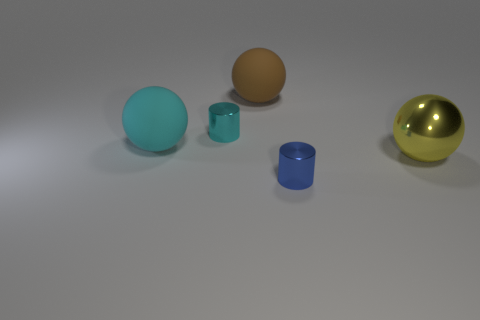Add 3 blue cylinders. How many objects exist? 8 Subtract all cylinders. How many objects are left? 3 Add 5 large cyan objects. How many large cyan objects exist? 6 Subtract 0 purple cylinders. How many objects are left? 5 Subtract all big yellow cylinders. Subtract all cyan shiny things. How many objects are left? 4 Add 5 yellow metallic things. How many yellow metallic things are left? 6 